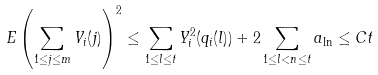Convert formula to latex. <formula><loc_0><loc_0><loc_500><loc_500>E \left ( \sum _ { 1 \leq j \leq m } V _ { i } ( j ) \right ) ^ { 2 } \leq \sum _ { 1 \leq l \leq t } Y ^ { 2 } _ { i } ( q _ { i } ( l ) ) + 2 \sum _ { 1 \leq l < n \leq t } a _ { \ln } \leq C t</formula> 